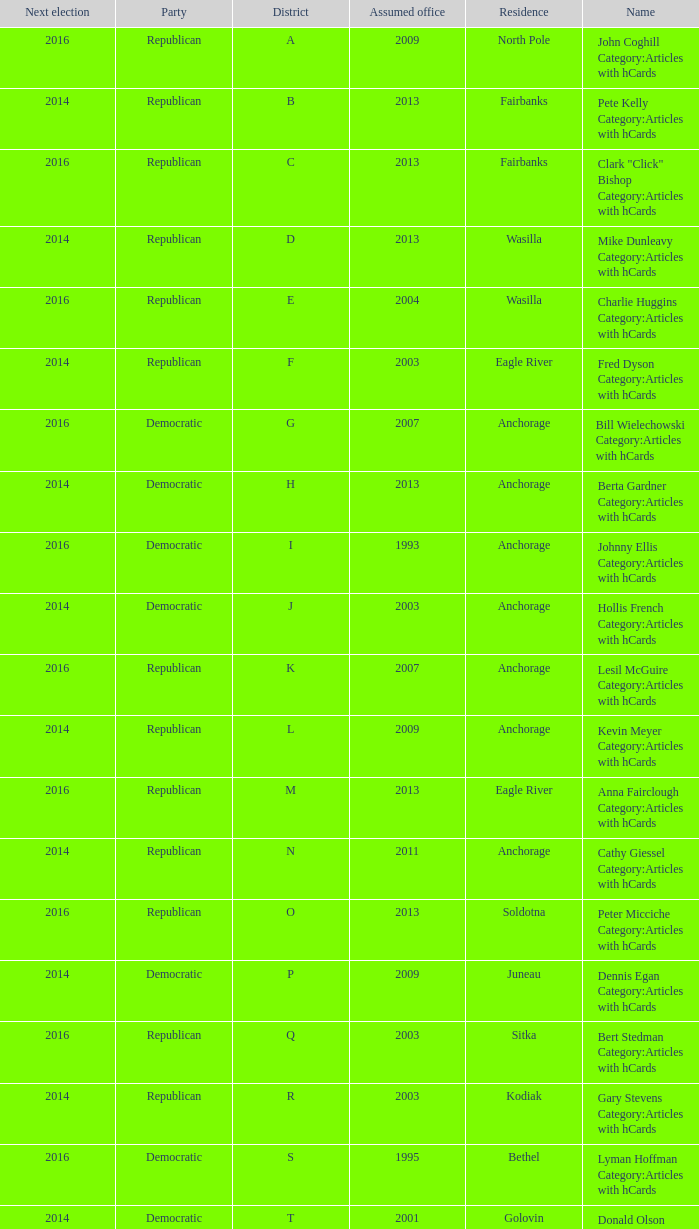What is the party of the Senator in District A, who assumed office before 2013 and will be up for re-election after 2014? Republican. Can you parse all the data within this table? {'header': ['Next election', 'Party', 'District', 'Assumed office', 'Residence', 'Name'], 'rows': [['2016', 'Republican', 'A', '2009', 'North Pole', 'John Coghill Category:Articles with hCards'], ['2014', 'Republican', 'B', '2013', 'Fairbanks', 'Pete Kelly Category:Articles with hCards'], ['2016', 'Republican', 'C', '2013', 'Fairbanks', 'Clark "Click" Bishop Category:Articles with hCards'], ['2014', 'Republican', 'D', '2013', 'Wasilla', 'Mike Dunleavy Category:Articles with hCards'], ['2016', 'Republican', 'E', '2004', 'Wasilla', 'Charlie Huggins Category:Articles with hCards'], ['2014', 'Republican', 'F', '2003', 'Eagle River', 'Fred Dyson Category:Articles with hCards'], ['2016', 'Democratic', 'G', '2007', 'Anchorage', 'Bill Wielechowski Category:Articles with hCards'], ['2014', 'Democratic', 'H', '2013', 'Anchorage', 'Berta Gardner Category:Articles with hCards'], ['2016', 'Democratic', 'I', '1993', 'Anchorage', 'Johnny Ellis Category:Articles with hCards'], ['2014', 'Democratic', 'J', '2003', 'Anchorage', 'Hollis French Category:Articles with hCards'], ['2016', 'Republican', 'K', '2007', 'Anchorage', 'Lesil McGuire Category:Articles with hCards'], ['2014', 'Republican', 'L', '2009', 'Anchorage', 'Kevin Meyer Category:Articles with hCards'], ['2016', 'Republican', 'M', '2013', 'Eagle River', 'Anna Fairclough Category:Articles with hCards'], ['2014', 'Republican', 'N', '2011', 'Anchorage', 'Cathy Giessel Category:Articles with hCards'], ['2016', 'Republican', 'O', '2013', 'Soldotna', 'Peter Micciche Category:Articles with hCards'], ['2014', 'Democratic', 'P', '2009', 'Juneau', 'Dennis Egan Category:Articles with hCards'], ['2016', 'Republican', 'Q', '2003', 'Sitka', 'Bert Stedman Category:Articles with hCards'], ['2014', 'Republican', 'R', '2003', 'Kodiak', 'Gary Stevens Category:Articles with hCards'], ['2016', 'Democratic', 'S', '1995', 'Bethel', 'Lyman Hoffman Category:Articles with hCards'], ['2014', 'Democratic', 'T', '2001', 'Golovin', 'Donald Olson Category:Articles with hCards']]} 